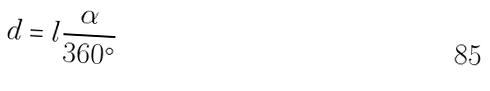Convert formula to latex. <formula><loc_0><loc_0><loc_500><loc_500>d = l \frac { \alpha } { 3 6 0 ^ { \circ } }</formula> 